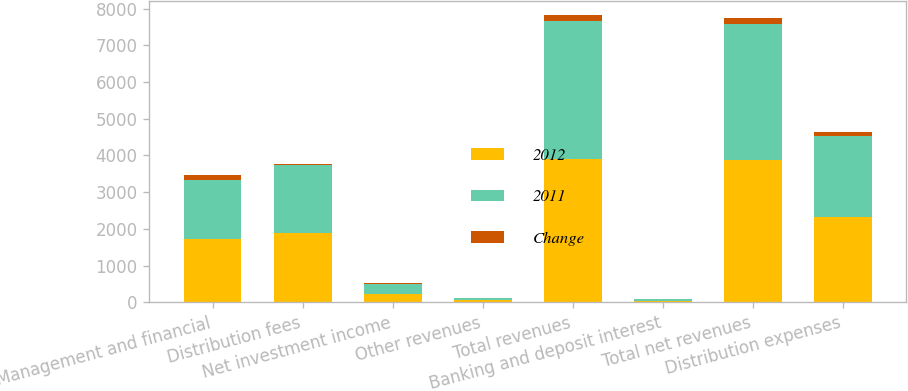Convert chart. <chart><loc_0><loc_0><loc_500><loc_500><stacked_bar_chart><ecel><fcel>Management and financial<fcel>Distribution fees<fcel>Net investment income<fcel>Other revenues<fcel>Total revenues<fcel>Banking and deposit interest<fcel>Total net revenues<fcel>Distribution expenses<nl><fcel>2012<fcel>1737<fcel>1879<fcel>233<fcel>64<fcel>3913<fcel>40<fcel>3873<fcel>2324<nl><fcel>2011<fcel>1590<fcel>1849<fcel>261<fcel>61<fcel>3761<fcel>48<fcel>3713<fcel>2203<nl><fcel>Change<fcel>147<fcel>30<fcel>28<fcel>3<fcel>152<fcel>8<fcel>160<fcel>121<nl></chart> 